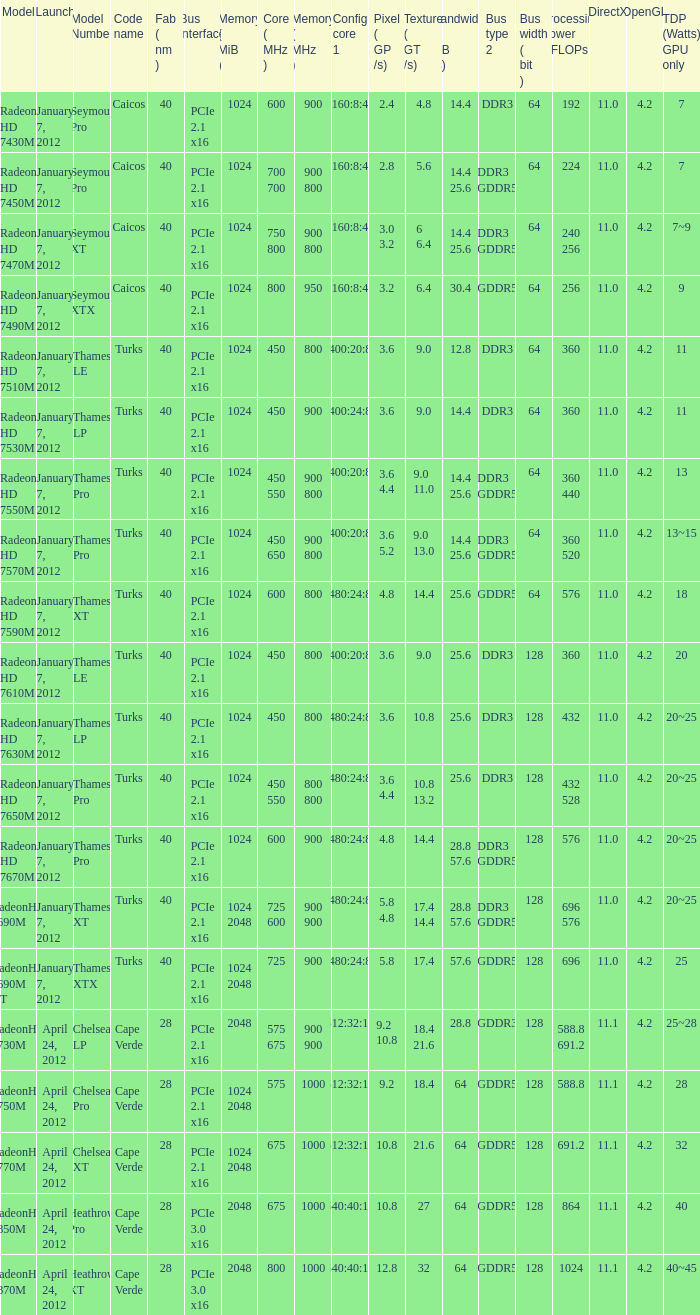What is the number of texture (gt/s) for the card with a 18 watts tdp gpu? 1.0. 